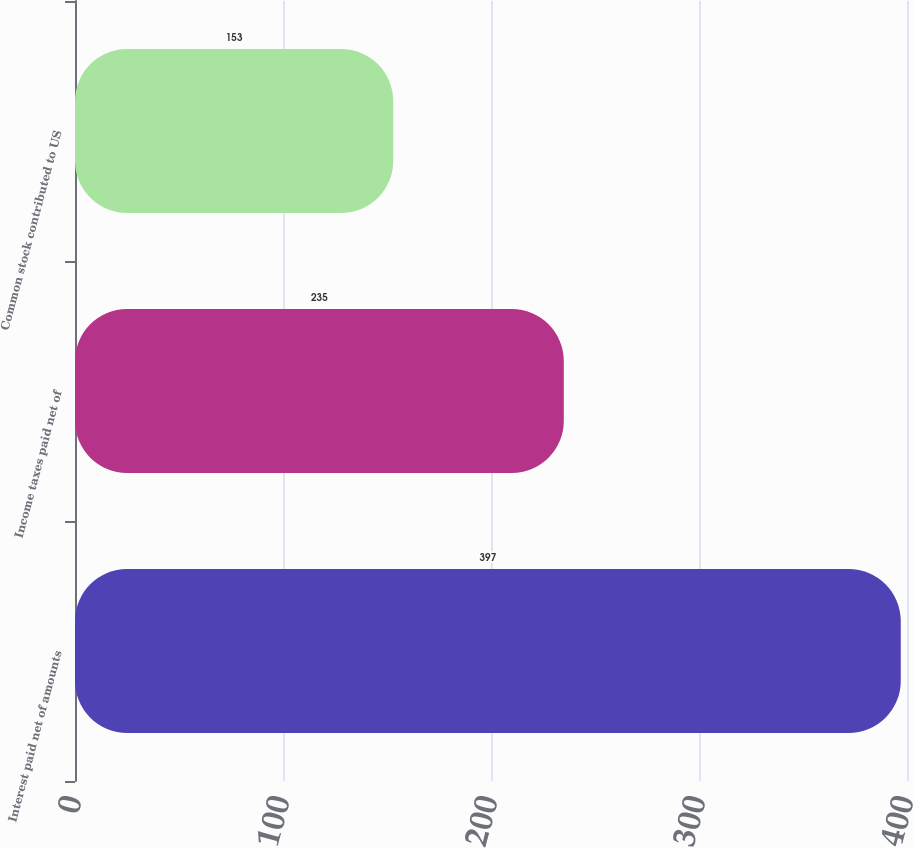Convert chart. <chart><loc_0><loc_0><loc_500><loc_500><bar_chart><fcel>Interest paid net of amounts<fcel>Income taxes paid net of<fcel>Common stock contributed to US<nl><fcel>397<fcel>235<fcel>153<nl></chart> 